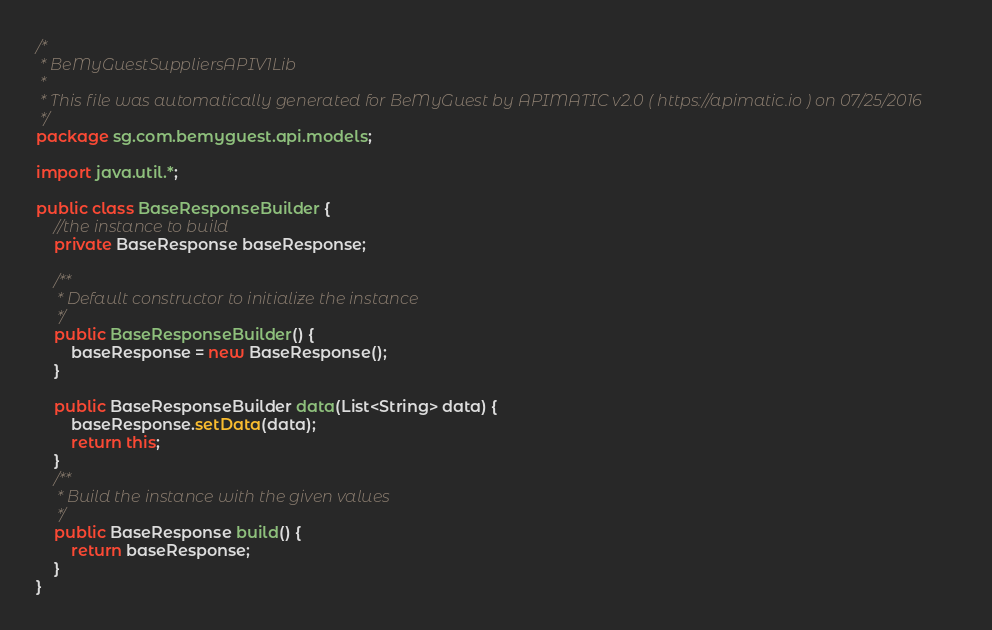Convert code to text. <code><loc_0><loc_0><loc_500><loc_500><_Java_>/*
 * BeMyGuestSuppliersAPIV1Lib
 *
 * This file was automatically generated for BeMyGuest by APIMATIC v2.0 ( https://apimatic.io ) on 07/25/2016
 */
package sg.com.bemyguest.api.models;

import java.util.*;

public class BaseResponseBuilder {
    //the instance to build
    private BaseResponse baseResponse;

    /**
     * Default constructor to initialize the instance
     */
    public BaseResponseBuilder() {
        baseResponse = new BaseResponse();
    }

    public BaseResponseBuilder data(List<String> data) {
        baseResponse.setData(data);
        return this;
    }
    /**
     * Build the instance with the given values
     */
    public BaseResponse build() {
        return baseResponse;
    }
}</code> 